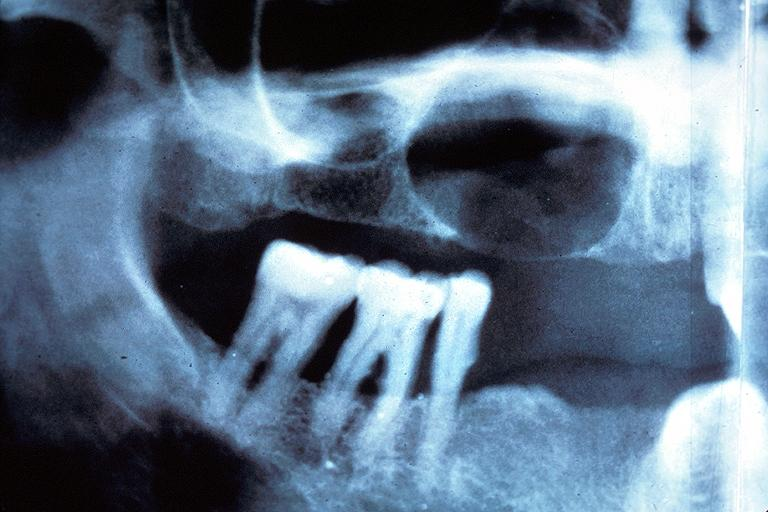where is this?
Answer the question using a single word or phrase. Oral 